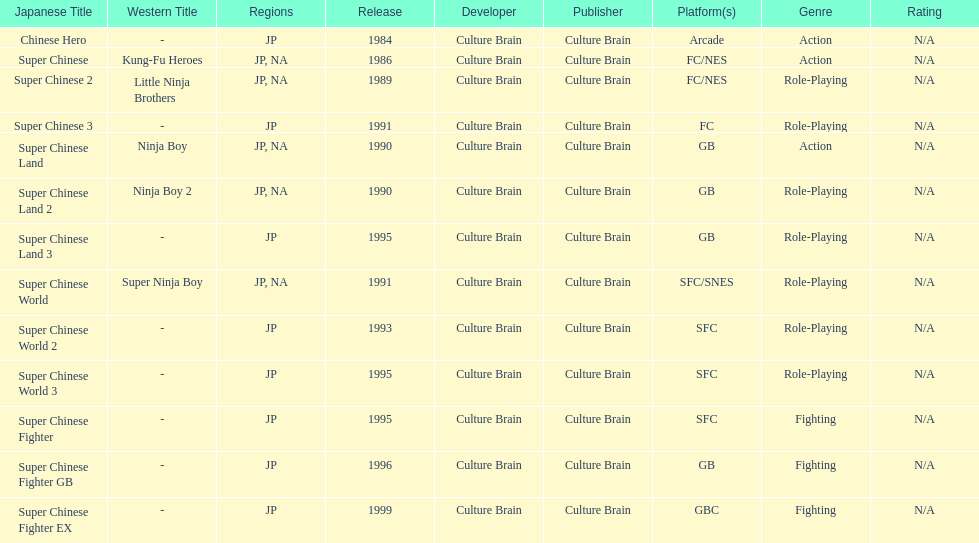Write the full table. {'header': ['Japanese Title', 'Western Title', 'Regions', 'Release', 'Developer', 'Publisher', 'Platform(s)', 'Genre', 'Rating'], 'rows': [['Chinese Hero', '-', 'JP', '1984', 'Culture Brain', 'Culture Brain', 'Arcade', 'Action', 'N/A'], ['Super Chinese', 'Kung-Fu Heroes', 'JP, NA', '1986', 'Culture Brain', 'Culture Brain', 'FC/NES', 'Action', 'N/A'], ['Super Chinese 2', 'Little Ninja Brothers', 'JP, NA', '1989', 'Culture Brain', 'Culture Brain', 'FC/NES', 'Role-Playing', 'N/A'], ['Super Chinese 3', '-', 'JP', '1991', 'Culture Brain', 'Culture Brain', 'FC', 'Role-Playing', 'N/A'], ['Super Chinese Land', 'Ninja Boy', 'JP, NA', '1990', 'Culture Brain', 'Culture Brain', 'GB', 'Action', 'N/A'], ['Super Chinese Land 2', 'Ninja Boy 2', 'JP, NA', '1990', 'Culture Brain', 'Culture Brain', 'GB', 'Role-Playing', 'N/A'], ['Super Chinese Land 3', '-', 'JP', '1995', 'Culture Brain', 'Culture Brain', 'GB', 'Role-Playing', 'N/A'], ['Super Chinese World', 'Super Ninja Boy', 'JP, NA', '1991', 'Culture Brain', 'Culture Brain', 'SFC/SNES', 'Role-Playing', 'N/A'], ['Super Chinese World 2', '-', 'JP', '1993', 'Culture Brain', 'Culture Brain', 'SFC', 'Role-Playing', 'N/A'], ['Super Chinese World 3', '-', 'JP', '1995', 'Culture Brain', 'Culture Brain', 'SFC', 'Role-Playing', 'N/A'], ['Super Chinese Fighter', '-', 'JP', '1995', 'Culture Brain', 'Culture Brain', 'SFC', 'Fighting', 'N/A'], ['Super Chinese Fighter GB', '-', 'JP', '1996', 'Culture Brain', 'Culture Brain', 'GB', 'Fighting', 'N/A'], ['Super Chinese Fighter EX', '-', 'JP', '1999', 'Culture Brain', 'Culture Brain', 'GBC', 'Fighting', 'N/A']]} The first year a game was released in north america 1986. 